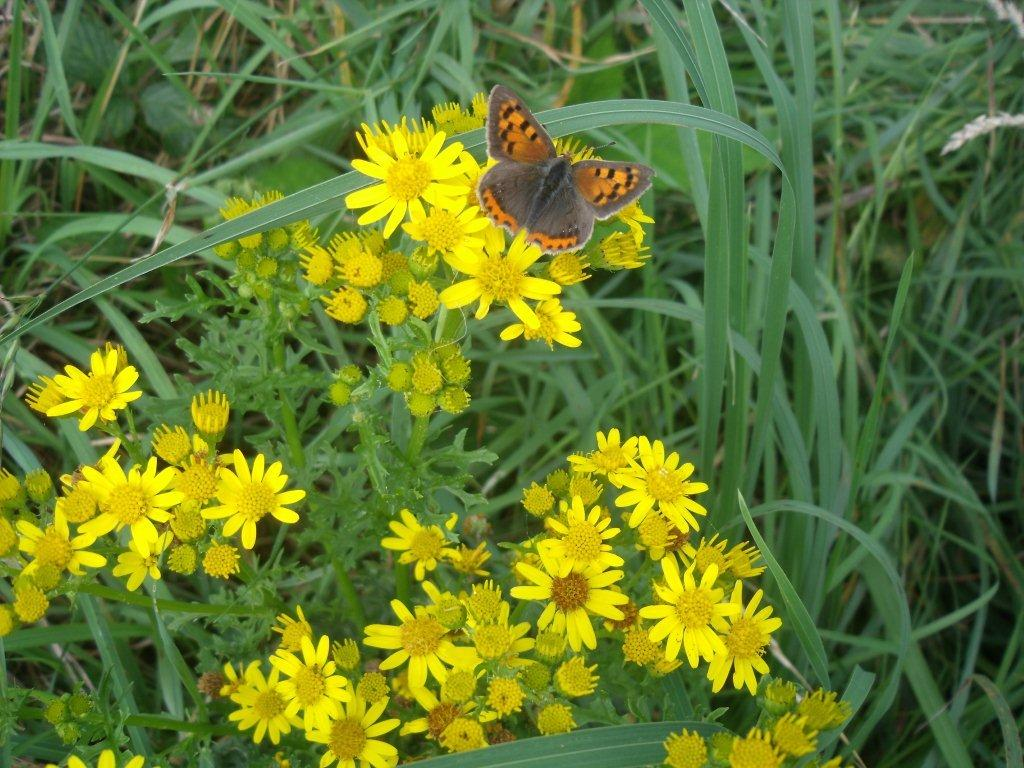What type of creature can be seen in the image? There is an insect in the image. What other natural elements are present in the image? There are flowers and grass in the image. What type of fire can be seen in the image? There is no fire present in the image; it features an insect, flowers, and grass. What kind of lunch is being served in the image? There is no lunch or any food item present in the image. 